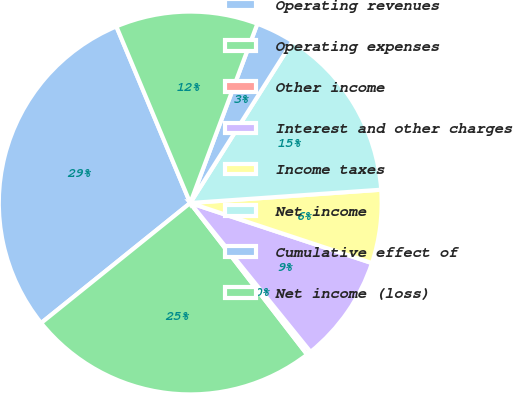<chart> <loc_0><loc_0><loc_500><loc_500><pie_chart><fcel>Operating revenues<fcel>Operating expenses<fcel>Other income<fcel>Interest and other charges<fcel>Income taxes<fcel>Net income<fcel>Cumulative effect of<fcel>Net income (loss)<nl><fcel>29.48%<fcel>24.67%<fcel>0.36%<fcel>9.1%<fcel>6.19%<fcel>14.92%<fcel>3.27%<fcel>12.01%<nl></chart> 